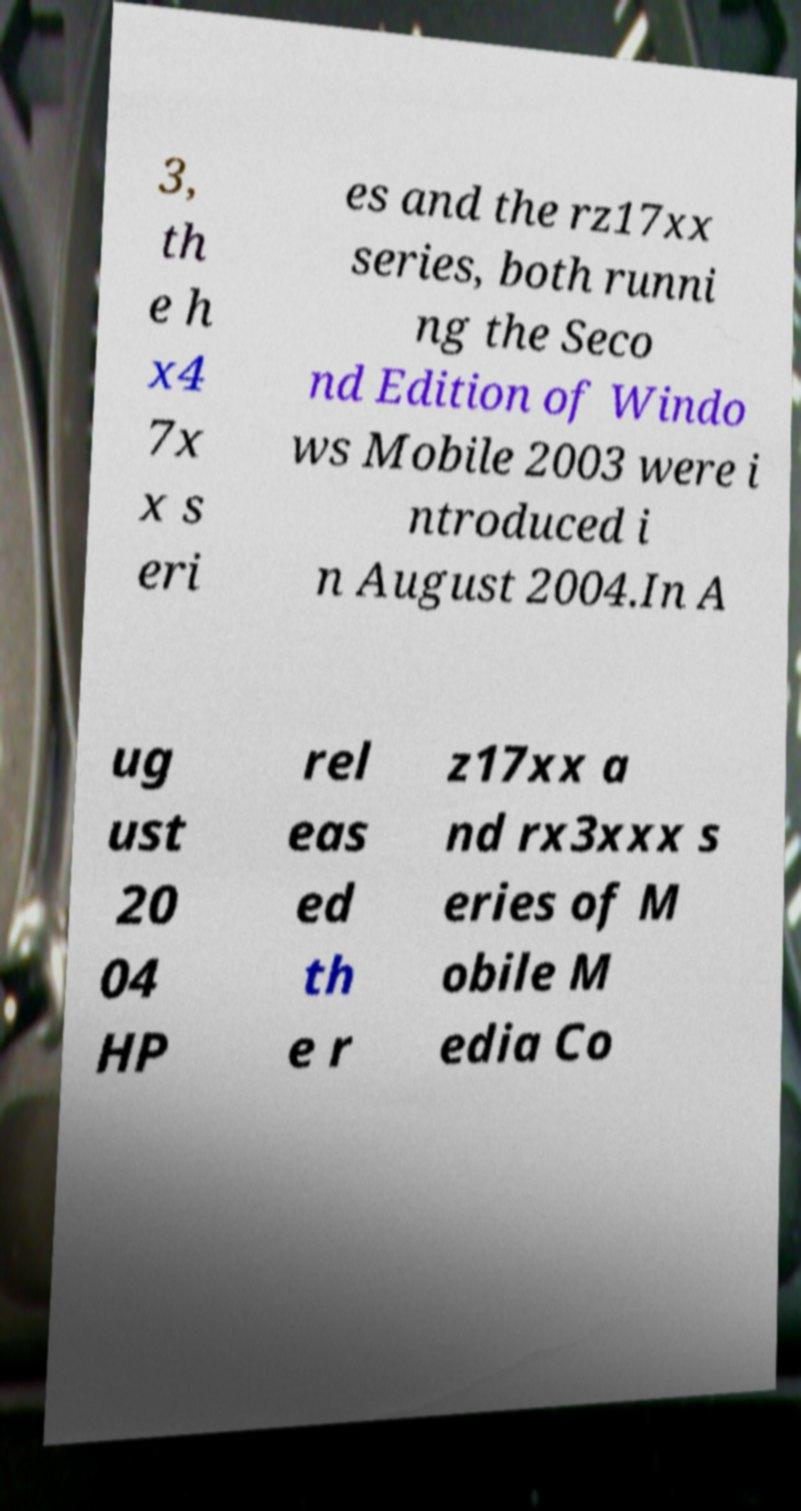There's text embedded in this image that I need extracted. Can you transcribe it verbatim? 3, th e h x4 7x x s eri es and the rz17xx series, both runni ng the Seco nd Edition of Windo ws Mobile 2003 were i ntroduced i n August 2004.In A ug ust 20 04 HP rel eas ed th e r z17xx a nd rx3xxx s eries of M obile M edia Co 